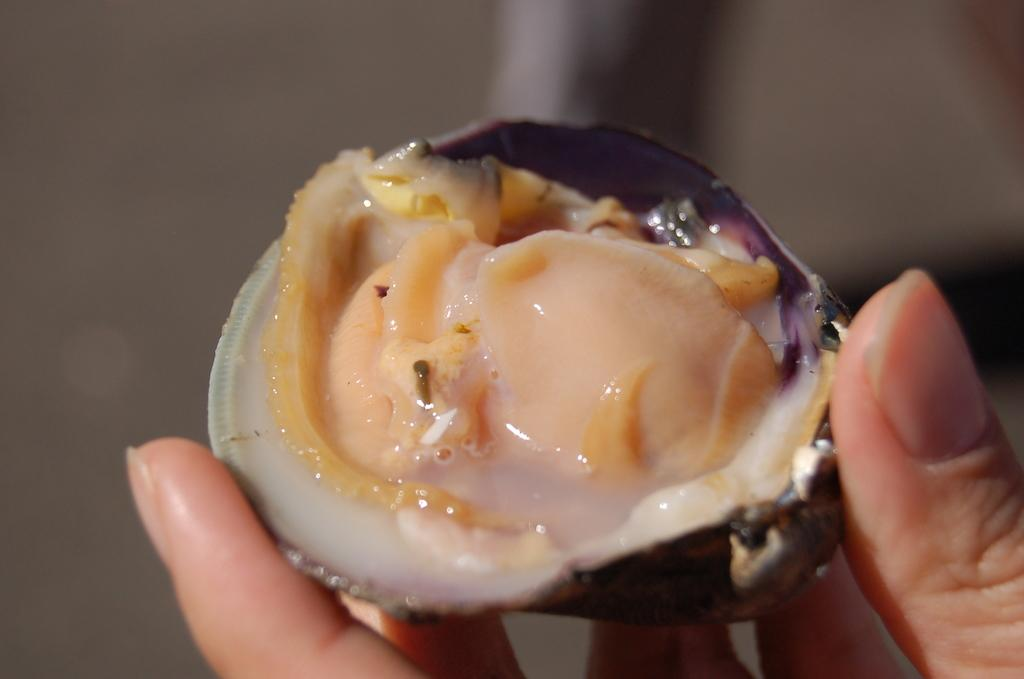What is the main subject of the image? The main subject of the image is a person's hand holding an oyster. Where is the hand located in the image? The hand is on the right side of the image. Can you describe the background of the image? The background of the image is blurred. What type of beast is visible in the image? There is no beast present in the image; it features a person's hand holding an oyster. What color is the sock worn by the person in the image? There is no sock visible in the image, as only the person's hand holding an oyster is shown. 